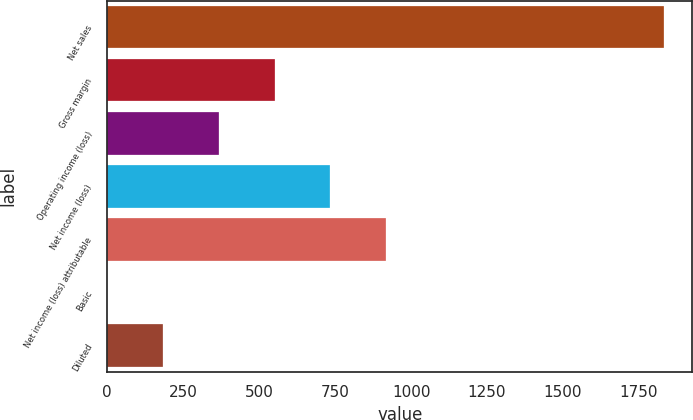Convert chart to OTSL. <chart><loc_0><loc_0><loc_500><loc_500><bar_chart><fcel>Net sales<fcel>Gross margin<fcel>Operating income (loss)<fcel>Net income (loss)<fcel>Net income (loss) attributable<fcel>Basic<fcel>Diluted<nl><fcel>1834<fcel>550.38<fcel>367.01<fcel>733.75<fcel>917.12<fcel>0.27<fcel>183.64<nl></chart> 